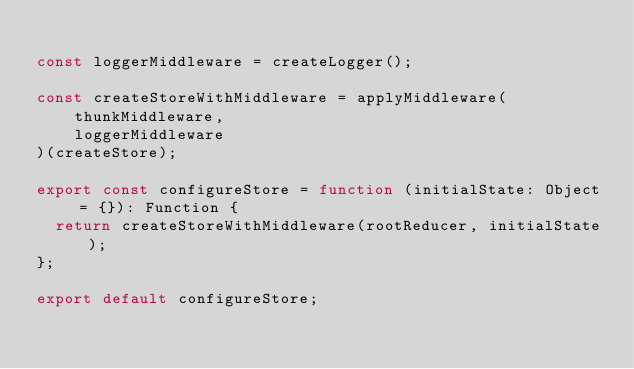Convert code to text. <code><loc_0><loc_0><loc_500><loc_500><_JavaScript_>
const loggerMiddleware = createLogger();

const createStoreWithMiddleware = applyMiddleware(
  	thunkMiddleware,
  	loggerMiddleware
)(createStore);

export const configureStore = function (initialState: Object = {}): Function {
  return createStoreWithMiddleware(rootReducer, initialState);
};

export default configureStore;
</code> 